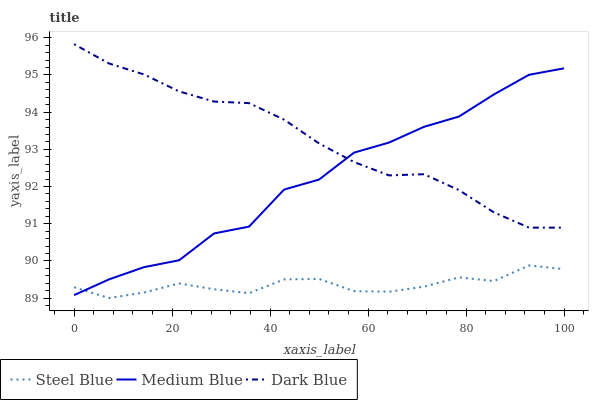Does Medium Blue have the minimum area under the curve?
Answer yes or no. No. Does Medium Blue have the maximum area under the curve?
Answer yes or no. No. Is Steel Blue the smoothest?
Answer yes or no. No. Is Steel Blue the roughest?
Answer yes or no. No. Does Medium Blue have the lowest value?
Answer yes or no. No. Does Medium Blue have the highest value?
Answer yes or no. No. Is Steel Blue less than Dark Blue?
Answer yes or no. Yes. Is Dark Blue greater than Steel Blue?
Answer yes or no. Yes. Does Steel Blue intersect Dark Blue?
Answer yes or no. No. 